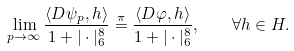Convert formula to latex. <formula><loc_0><loc_0><loc_500><loc_500>\lim _ { p \to \infty } \frac { \langle D \psi _ { p } , h \rangle } { 1 + | \cdot | _ { 6 } ^ { 8 } } \stackrel { \pi } { = } \frac { \langle D \varphi , h \rangle } { 1 + | \cdot | _ { 6 } ^ { 8 } } , \quad \forall h \in H .</formula> 